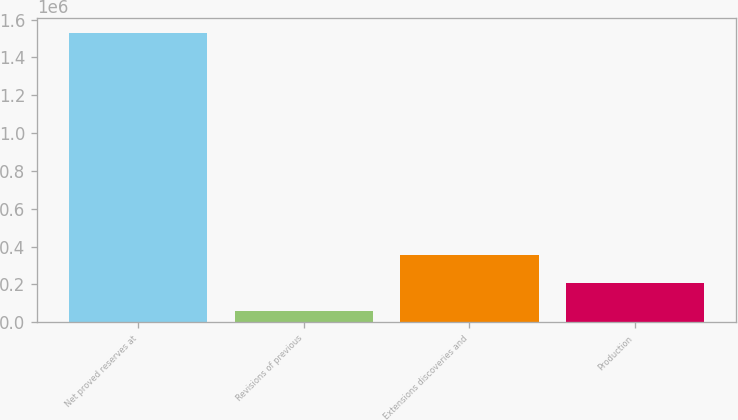Convert chart. <chart><loc_0><loc_0><loc_500><loc_500><bar_chart><fcel>Net proved reserves at<fcel>Revisions of previous<fcel>Extensions discoveries and<fcel>Production<nl><fcel>1.53168e+06<fcel>57935<fcel>352685<fcel>205310<nl></chart> 